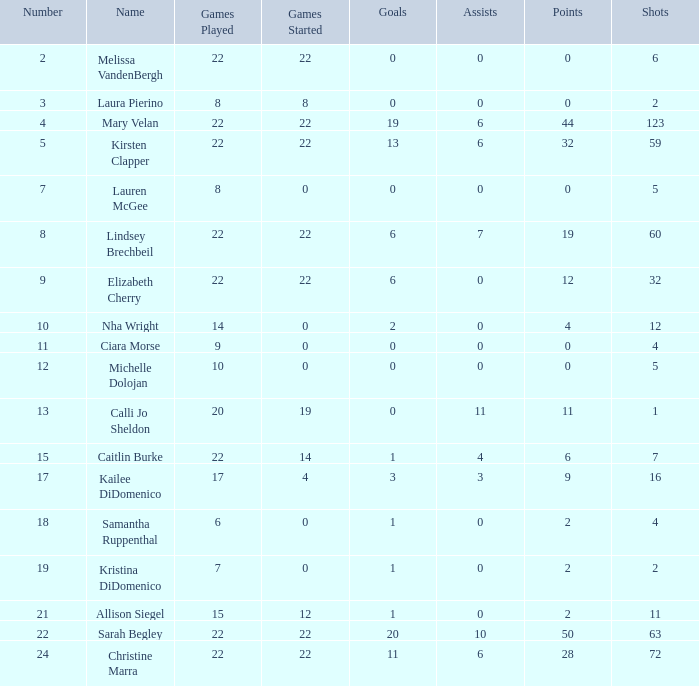How many numbers belong to the player with 10 assists?  1.0. 